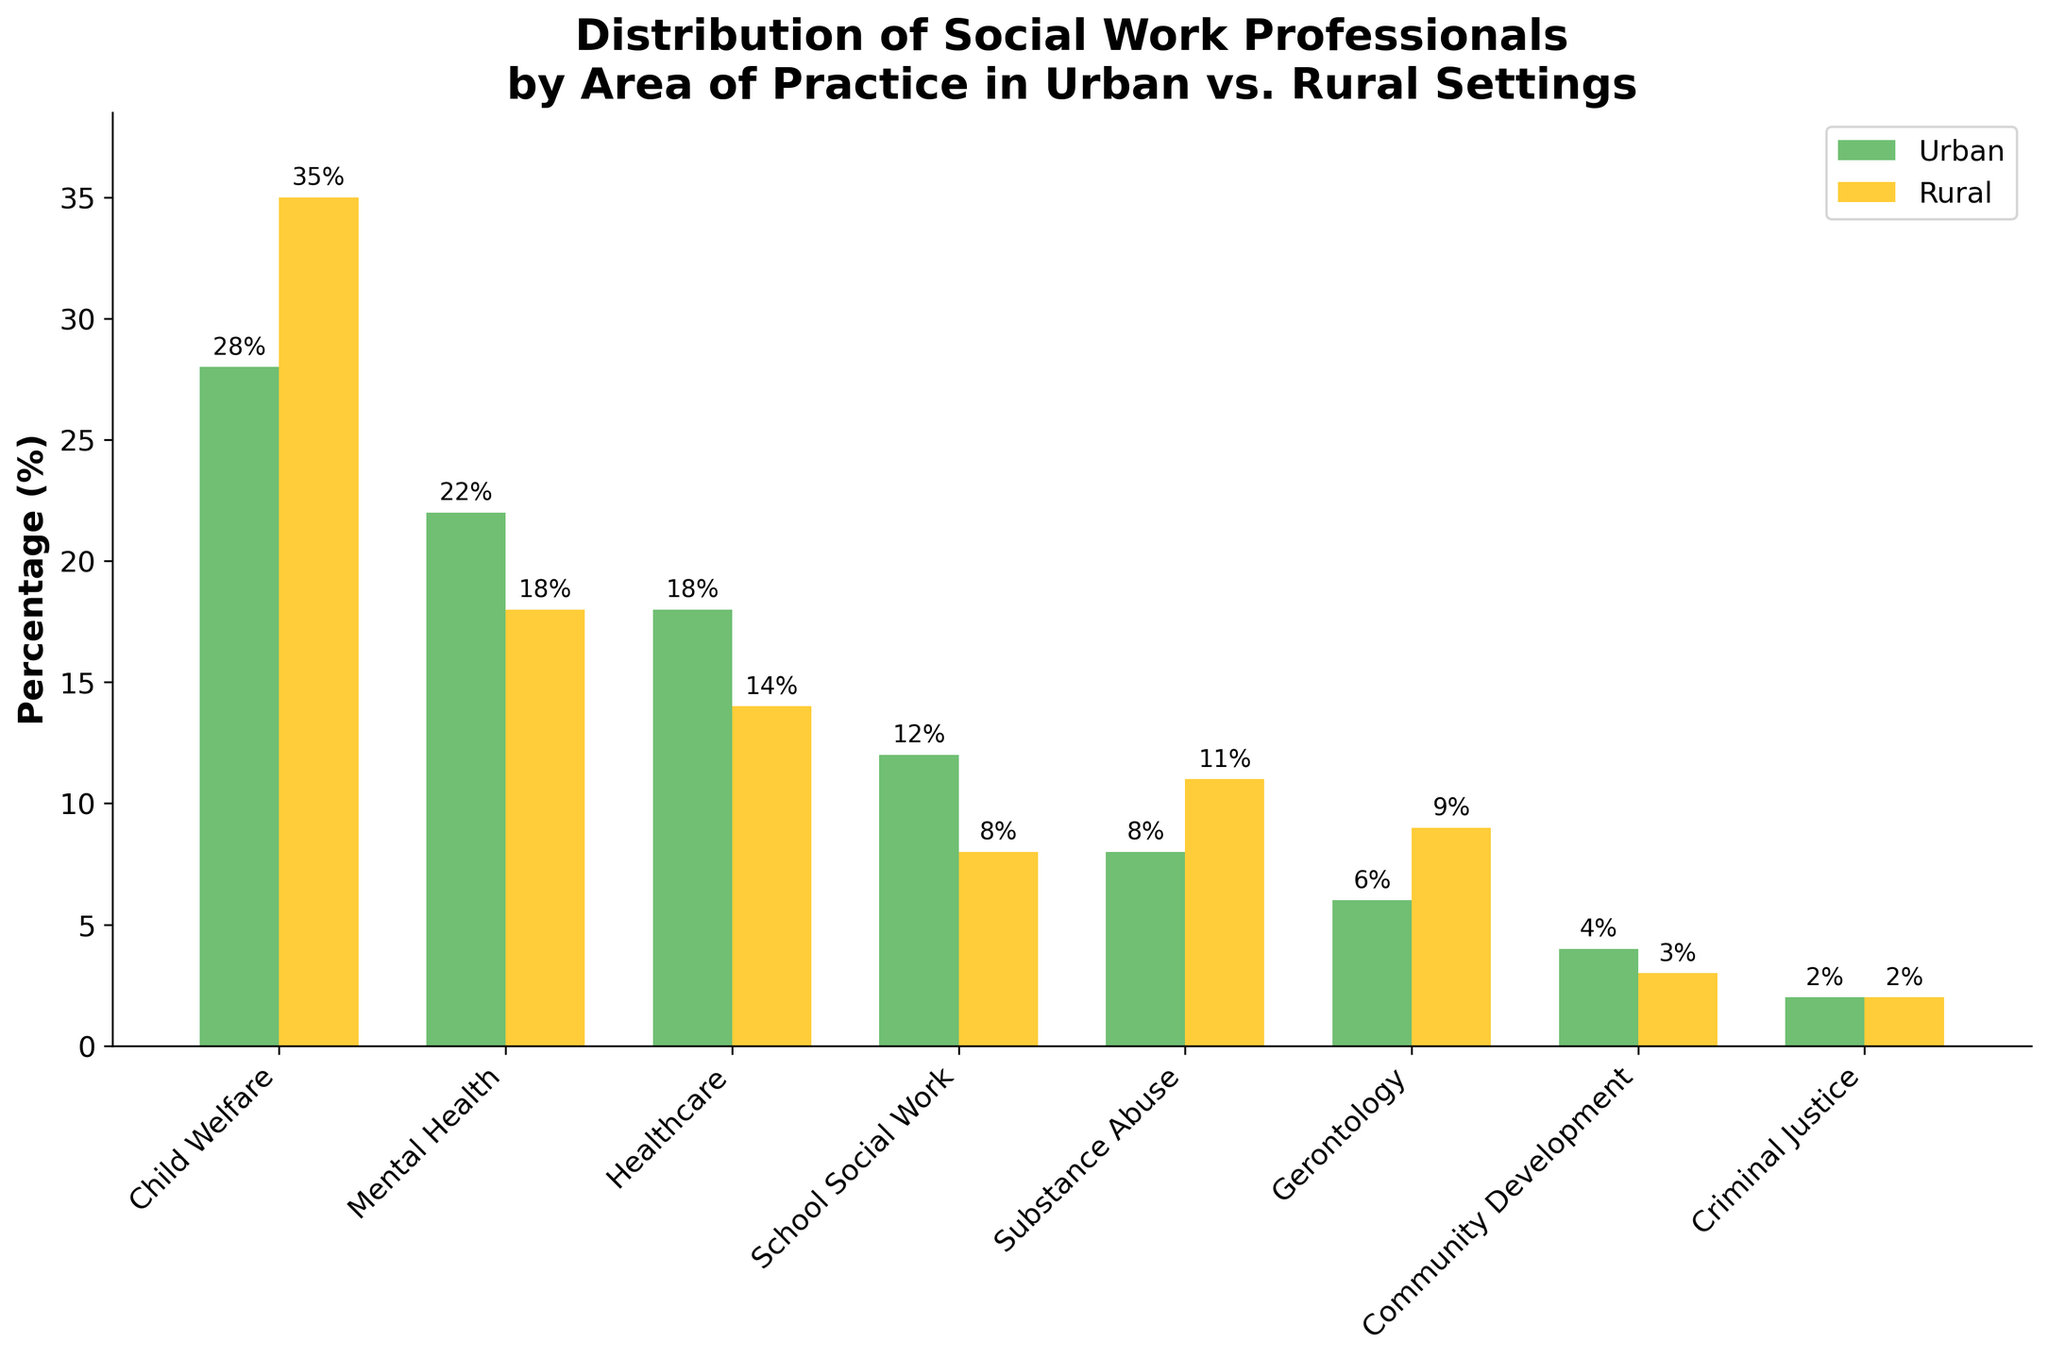What is the most common area of practice for social work professionals in urban settings? The tallest bar in the 'Urban' group indicates the most common area of practice. It shows 'Child Welfare' at 28%.
Answer: Child Welfare Which area of practice has the largest difference in percentage between urban and rural settings? Calculate the absolute differences between urban and rural percentages for each area. The largest difference is for 'Child Welfare' (35 - 28 = 7).
Answer: Child Welfare Are there any areas of practice where the percentage of social work professionals is equal in both urban and rural settings? Check if any bars in the urban group are of equal height to their corresponding bars in the rural group. Both bars for 'Criminal Justice' are the same height.
Answer: Criminal Justice What is the least common area of practice for social work professionals in rural settings? The shortest bar in the 'Rural' group indicates the least common area of practice. It shows 'Community Development' at 3%.
Answer: Community Development Between urban and rural settings, which setting has a higher percentage of social work professionals working in 'Substance Abuse'? Compare the height of the bars for 'Substance Abuse' in both groups. The 'Rural' bar is taller at 11% compared to the 'Urban' bar at 8%.
Answer: Rural What is the percentage difference between urban and rural settings in 'School Social Work'? Subtract the rural percentage (8%) from the urban percentage (12%) to find the difference. 12 - 8 = 4.
Answer: 4% Which areas of practice have a higher percentage of social work professionals in rural settings compared to urban settings? Compare bars for each area. 'Child Welfare', 'Substance Abuse', 'Gerontology', and 'Community Development' have taller bars in the rural group.
Answer: Child Welfare, Substance Abuse, Gerontology, Community Development How do the urban and rural percentages of 'Healthcare' compare? Compare the bars for 'Healthcare'. The urban bar is taller at 18%, while the rural bar is shorter at 14%.
Answer: Urban is higher What is the average percentage of social work professionals in the 'Urban' setting? Sum the urban percentages and divide by the number of areas (28 + 22 + 18 + 12 + 8 + 6 + 4 + 2 = 100, then 100 / 8 = 12.5).
Answer: 12.5% What is the combined percentage of 'Mental Health' and 'Gerontology' in rural settings? Add the rural percentages for 'Mental Health' (18%) and 'Gerontology' (9%). 18 + 9 = 27.
Answer: 27% 